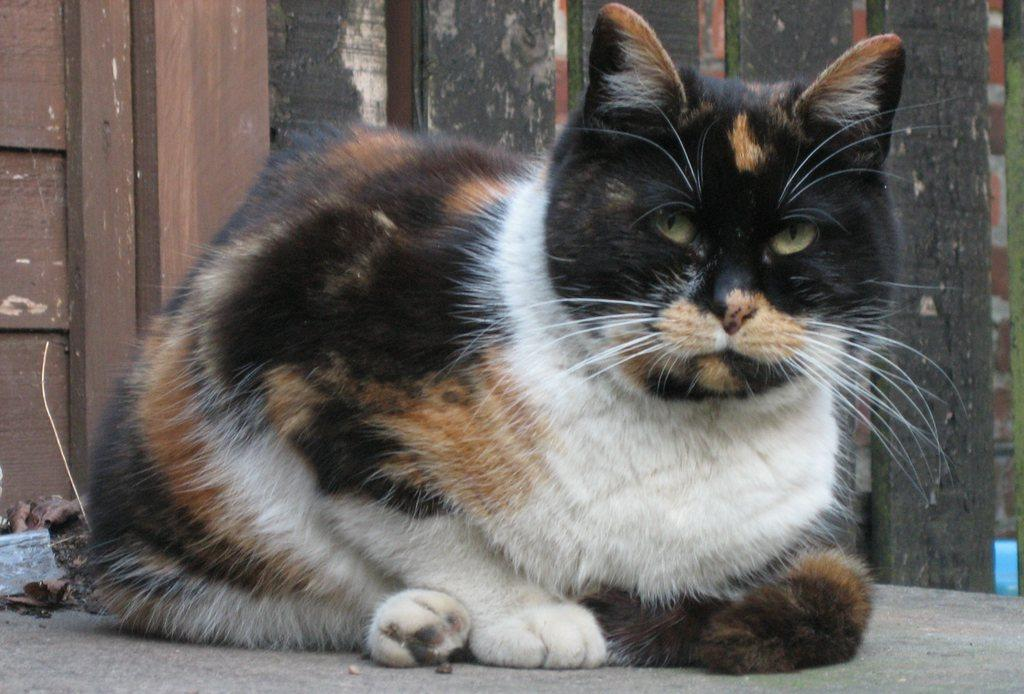What type of animal is in the image? There is a cat in the image. What is behind the cat in the image? There is a wooden wall behind the cat. What type of clothing is the scarecrow wearing in the image? There is no scarecrow present in the image; it features a cat and a wooden wall. How many fingers can be seen on the cat's friend in the image? There is no friend present in the image, as it only features a cat and a wooden wall. 